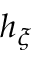Convert formula to latex. <formula><loc_0><loc_0><loc_500><loc_500>h _ { \xi }</formula> 